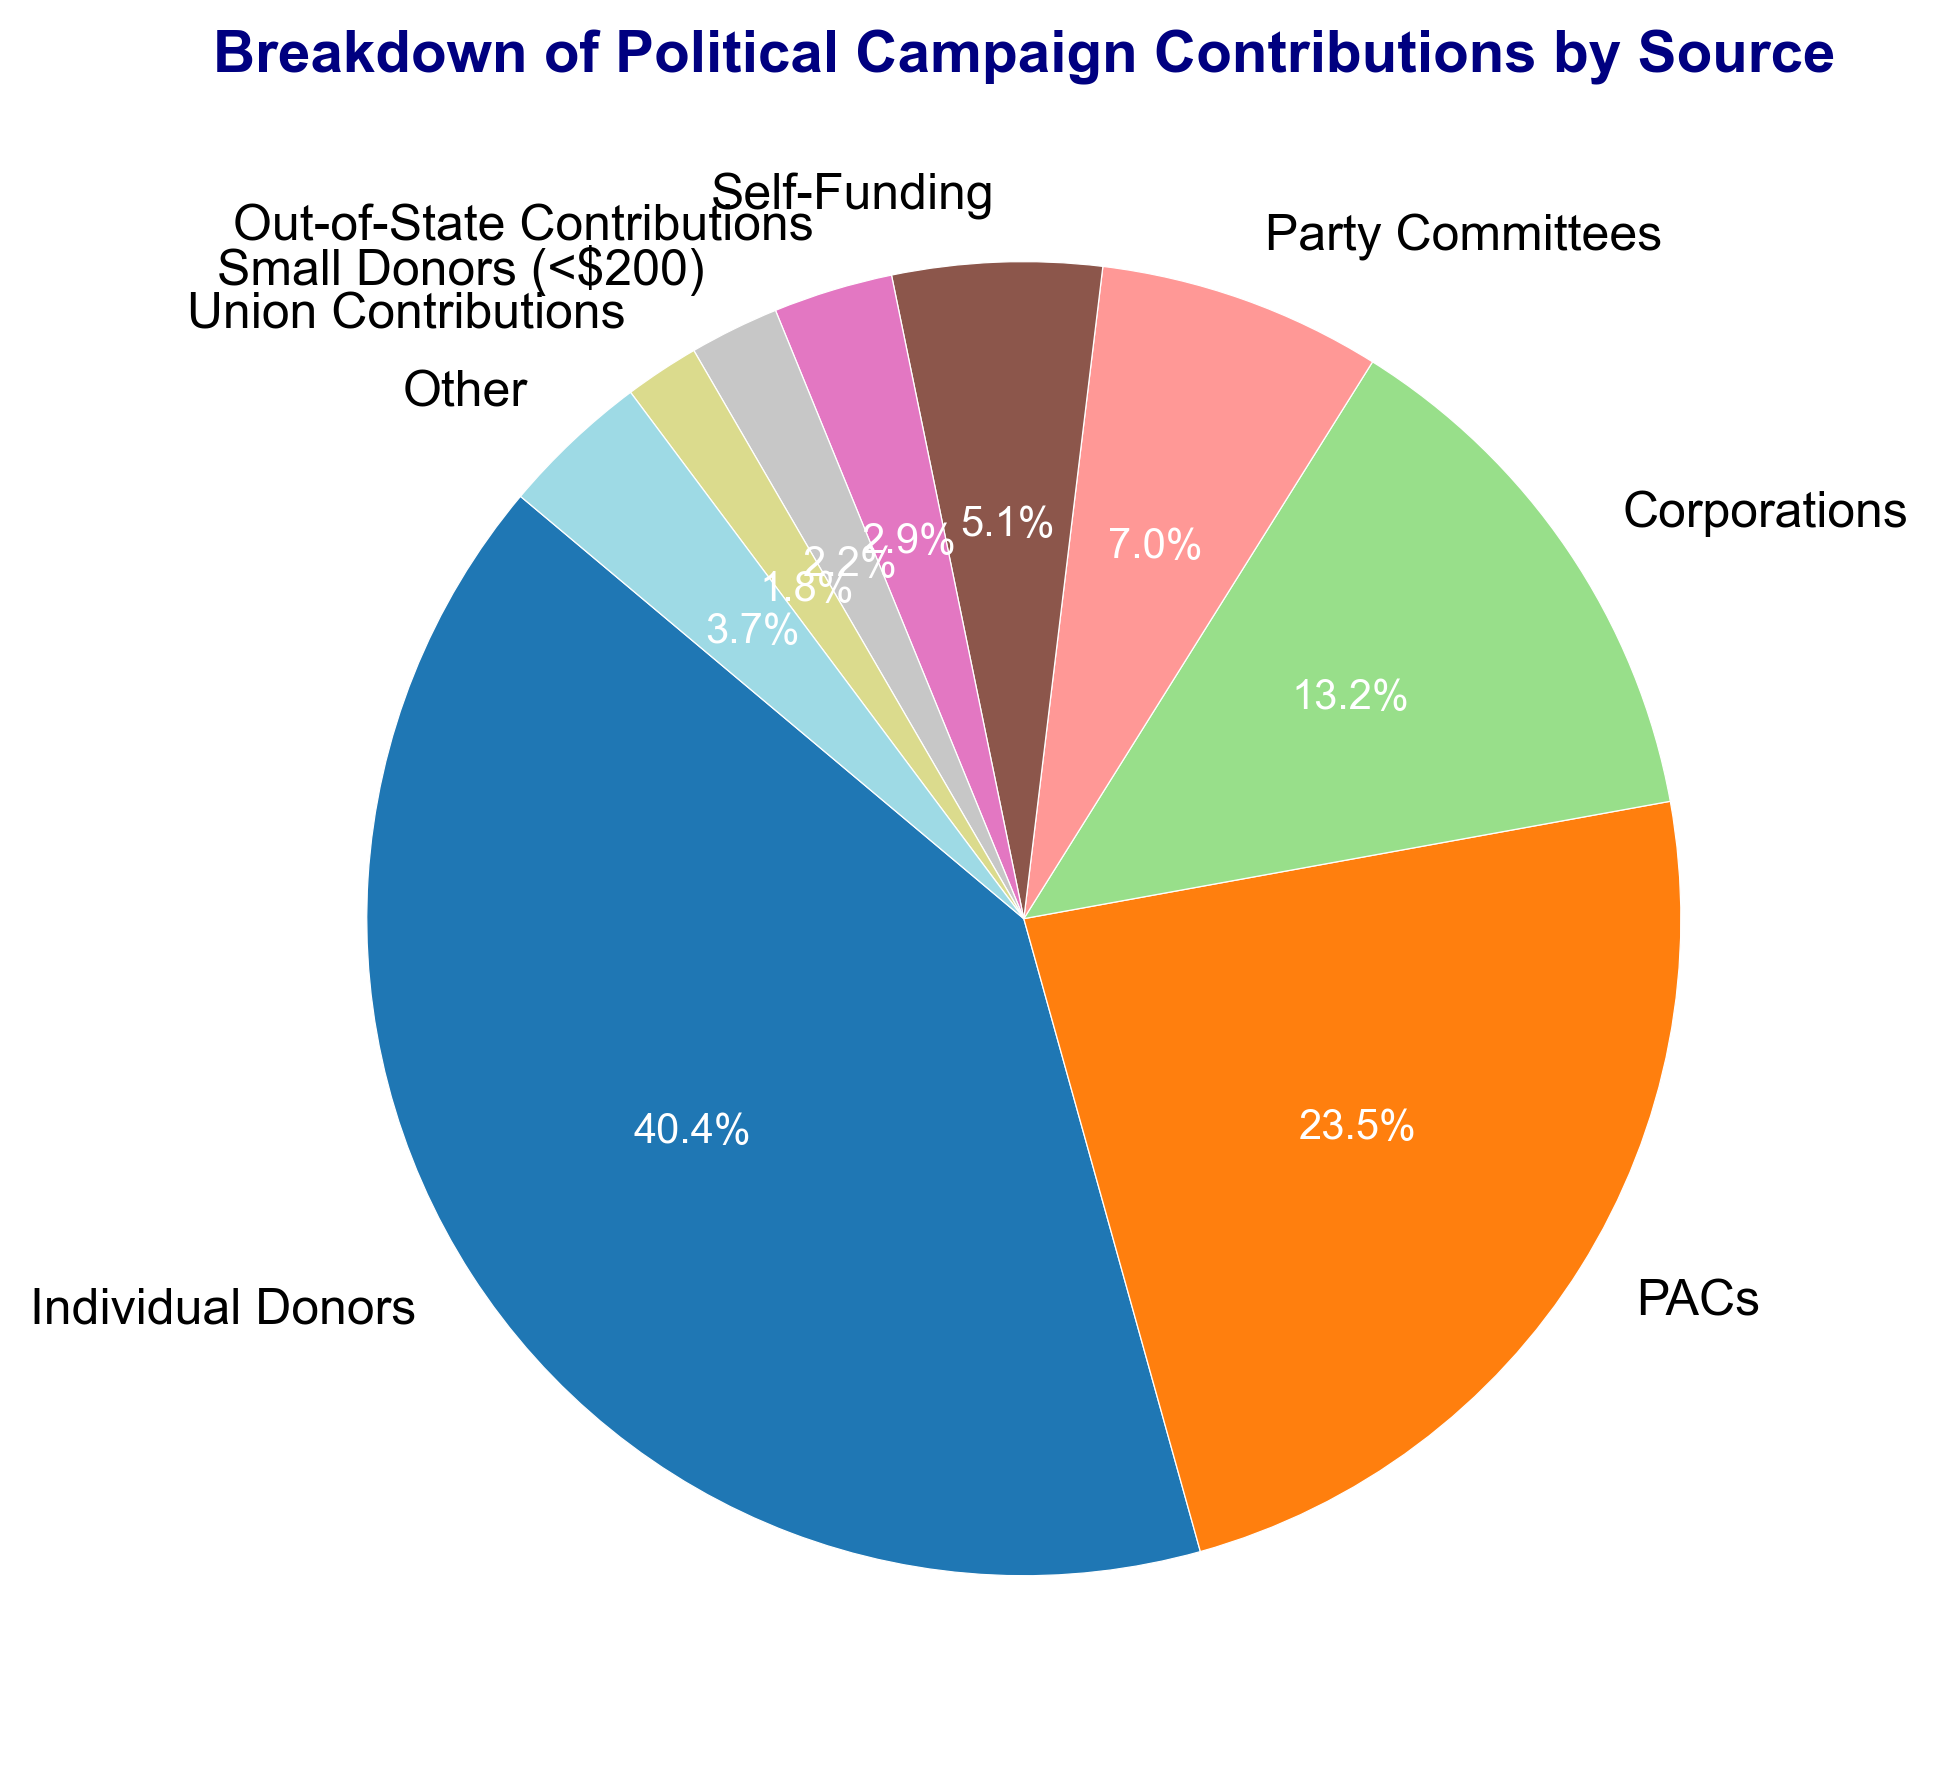What is the percentage share of Contributions from PACs? Locate the PACs segment on the pie chart. Find the percentage label on this segment.
Answer: 21.8% Which two sources provide the largest amount of contributions? Identify the two largest segments in the pie chart. They should be labeled with the source and percentage values.
Answer: Individual Donors and PACs How much more did Individual Donors contribute compared to Corporations? Find the amounts for Individual Donors ($5,500,000) and Corporations ($1,800,000). Subtract the latter from the former: $5,500,000 - $1,800,000.
Answer: $3,700,000 What is the total contribution amount from Party Committees, Self-Funding, and Union Contributions combined? Add the amounts for Party Committees ($950,000), Self-Funding ($700,000), and Union Contributions ($250,000): $950,000 + $700,000 + $250,000.
Answer: $1,900,000 Which source contributes the smallest amount, and what percentage of the total does it represent? Locate the smallest segment on the pie chart, which should be labeled Union Contributions. Find the percentage label on this segment.
Answer: Union Contributions, 1.5% Are contributions from Small Donors (<$200) larger or smaller than contributions from Out-of-State Contributions? Compare the sizes and corresponding percentages of the Small Donors (<$200) and Out-of-State Contributions segments on the pie chart.
Answer: Smaller What proportion of the total contributions is made by Self-Funding and Other combined? Find the percentages for Self-Funding (4.8%) and Other (3.4%). Add these percentages together: 4.8% + 3.4%.
Answer: 8.2% How does the contribution from Individual Donors compare with the sum of contributions from Corporations and Party Committees? Add the contributions from Corporations ($1,800,000) and Party Committees ($950,000): $1,800,000 + $950,000 = $2,750,000. Compare with the contribution from Individual Donors ($5,500,000).
Answer: Larger 